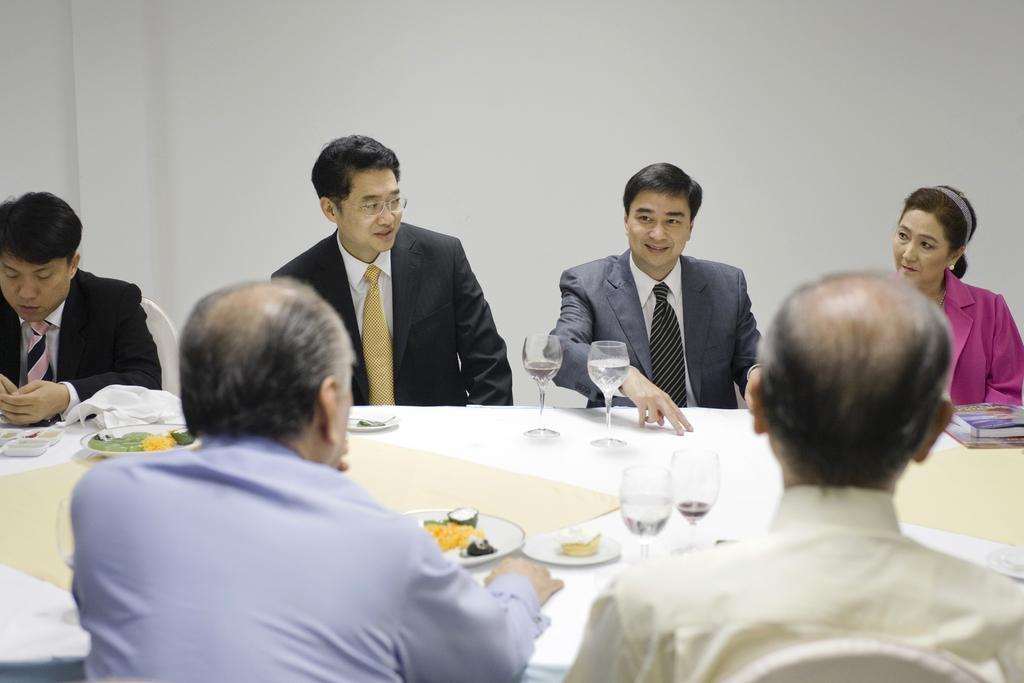Please provide a concise description of this image. There are persons in different color dresses, sitting on chairs around a table on which, there are glasses, plates which are having food items, a book and other objects. And this table is covered with a cloth. In the background, there is a white wall. 